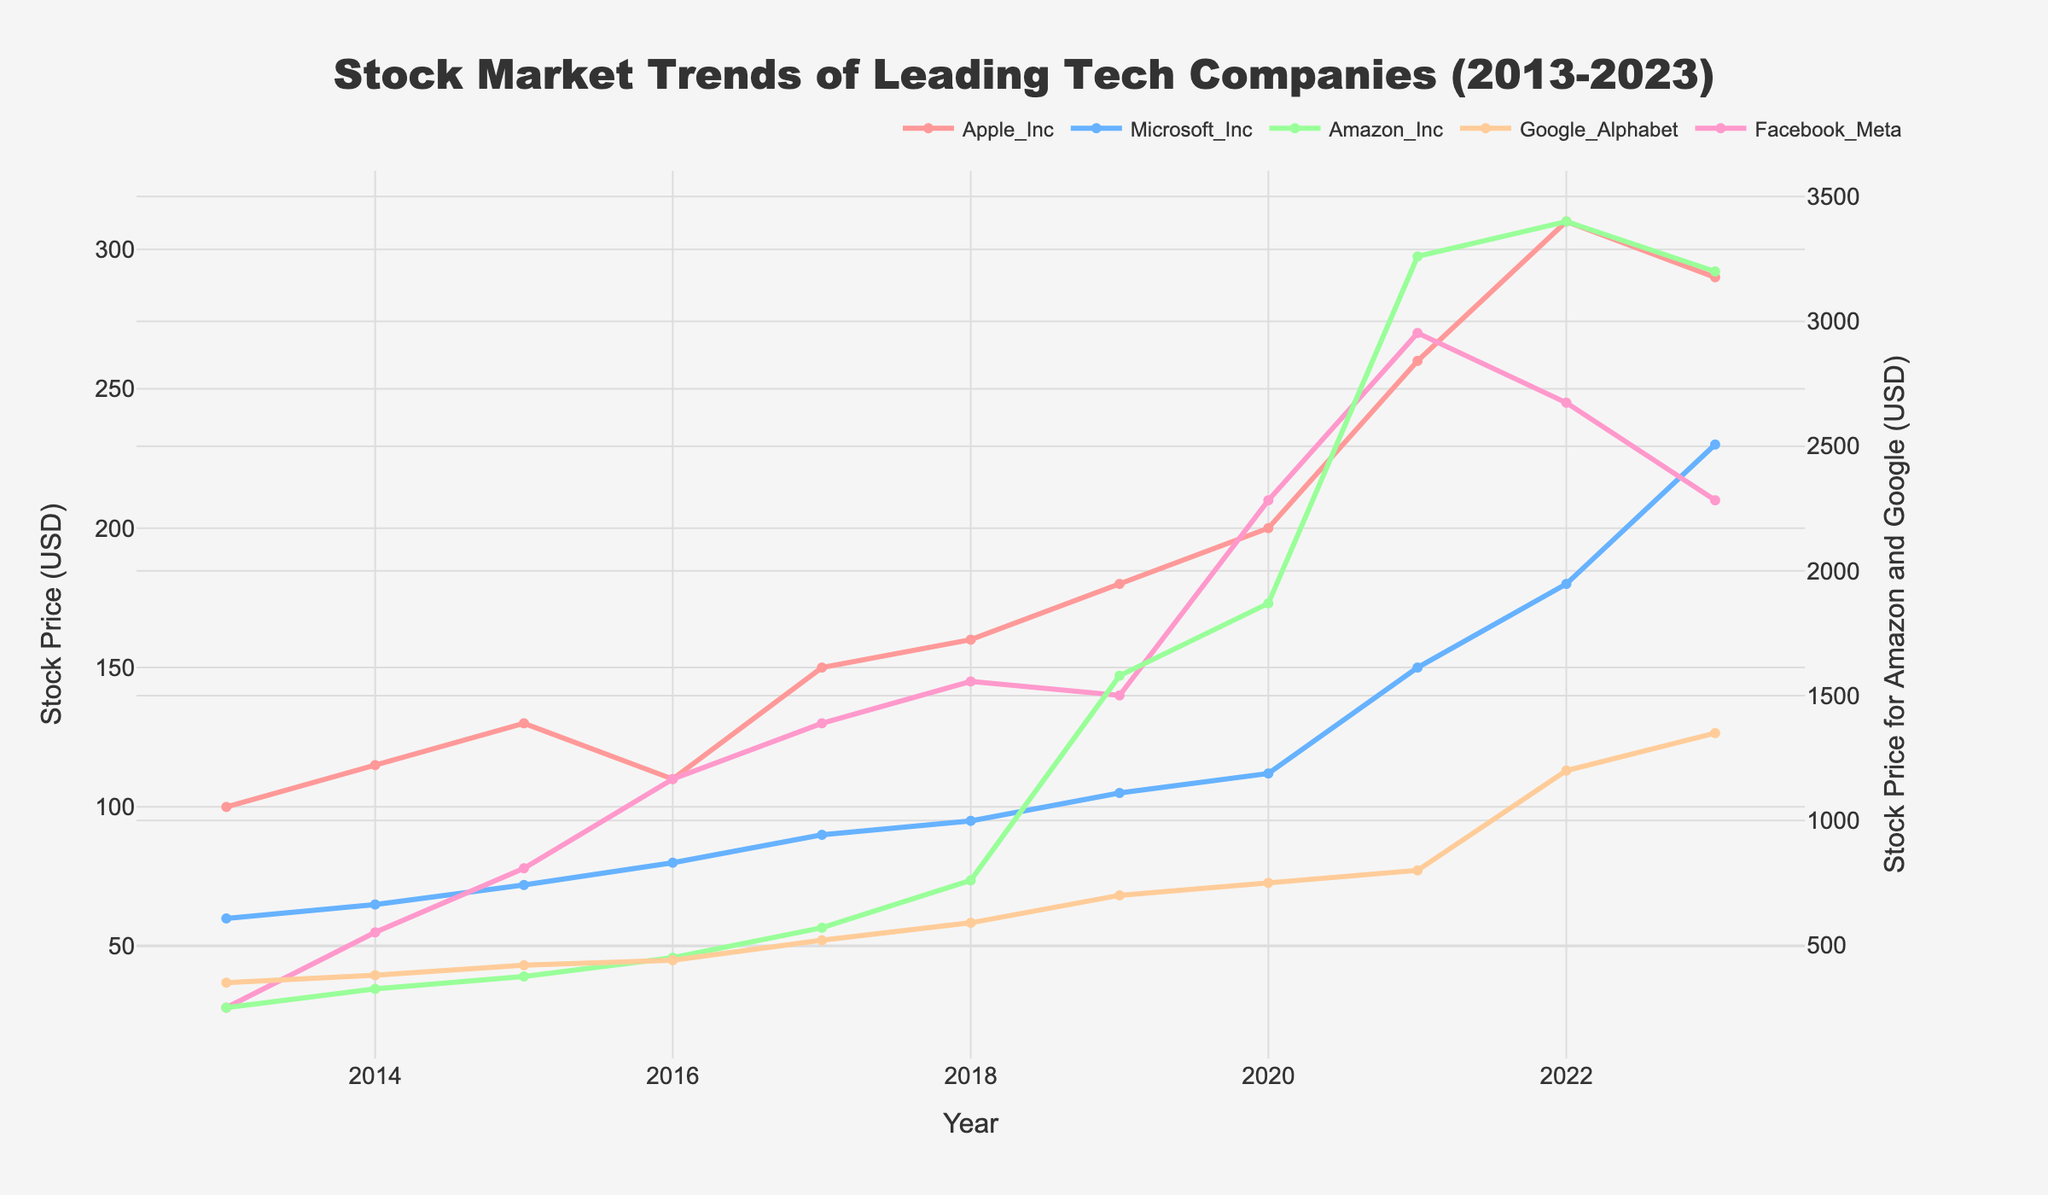What is the title of the plot? The title of the plot is prominently displayed at the top and reads "Stock Market Trends of Leading Tech Companies (2013-2023)".
Answer: Stock Market Trends of Leading Tech Companies (2013-2023) How many companies are tracked in the figure? The legend at the top of the figure lists all the companies being tracked. It shows a total of five companies.
Answer: Five Which company had the highest stock price in 2022? By looking at the Y-axis values and tracing along the year 2022, you can see that Amazon Inc. had the highest stock price, reaching 3400 USD.
Answer: Amazon Inc Between 2017 and 2018, which company's stock showed the highest increase in value? Comparing stock prices between 2017 and 2018 for each company, Amazon Inc. increased from 570 to 760, which is the highest increment of 190.
Answer: Amazon Inc Between which years did Google_Alphabet show the steepest increase in stock price? By comparing the slopes of the Google_Alphabet line, the steepest increase appears between 2021 and 2022, when the stock price jumps from 800 to 1200.
Answer: 2021 to 2022 What was the stock price of Microsoft Inc. in 2020? Referring to the line corresponding to Microsoft Inc., the stock price for the year 2020 is marked at 112 USD.
Answer: 112 USD Between 2019 and 2020, did Apple Inc.'s stock price increase or decrease? By observing the trend line for Apple Inc., the stock price increased from 180 in 2019 to 200 in 2020.
Answer: Increase Which years did Facebook_Meta's stock price decrease? The decreases in Facebook_Meta's stock price occurred between 2021 (270) and 2022 (245), and between 2022 and 2023 (210).
Answer: 2021 to 2022, 2022 to 2023 Between which years did Amazon Inc. experience the largest single-year increase in stock price? Comparing each year-over-year change for Amazon Inc., the largest jump was from 2020 to 2021, where the stock price rose from 1870 to 3260.
Answer: 2020 to 2021 What is the overall trend for Google_Alphabet's stock price from 2013 to 2023? Observing the trend line for Google_Alphabet, the stock price generally increased, showing significant growth particularly after 2015, culminating at 1350 in 2023.
Answer: Increasing 